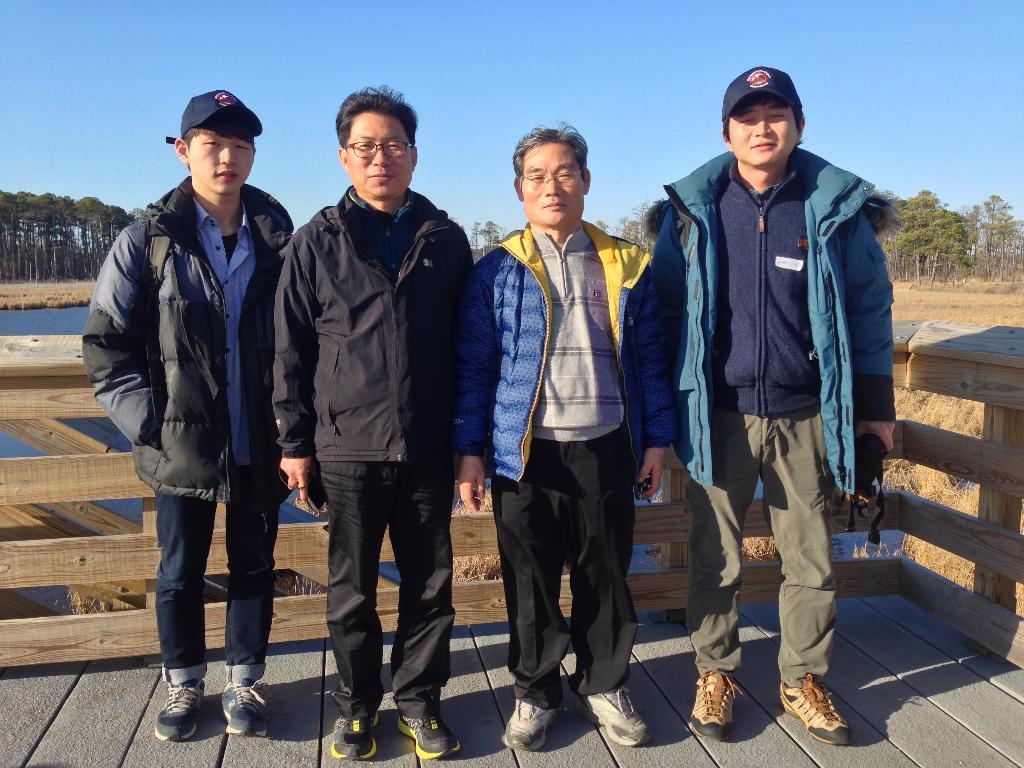Please provide a concise description of this image. In this image in front there are four people. Behind them there is a wooden fence. In the center of the image there is water. At the bottom of the image there is grass on the surface. In the background of the image there are trees and sky. 